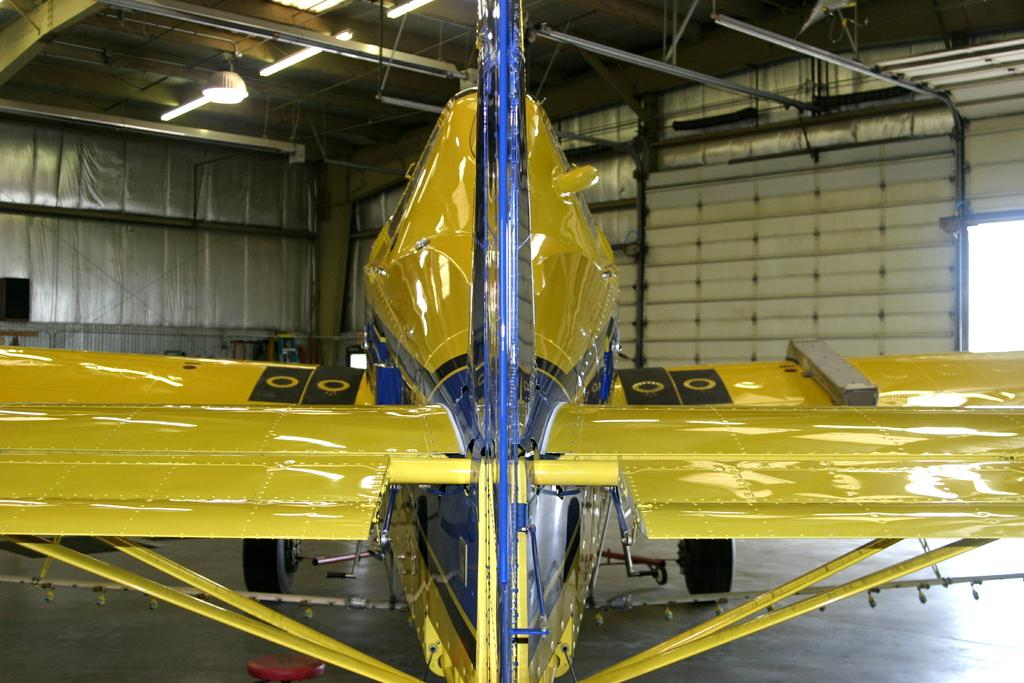What color is the aircraft in the image? The aircraft is yellow-blue in color. Where is the aircraft located in the image? The aircraft is on the floor. What type of walls can be seen in the background of the image? There are metal walls in the background of the image. What is attached to the roof in the image? Lights are attached to the roof in the image. What type of dress is the aircraft wearing in the image? The aircraft is not wearing a dress, as it is an inanimate object and does not have the ability to wear clothing. 